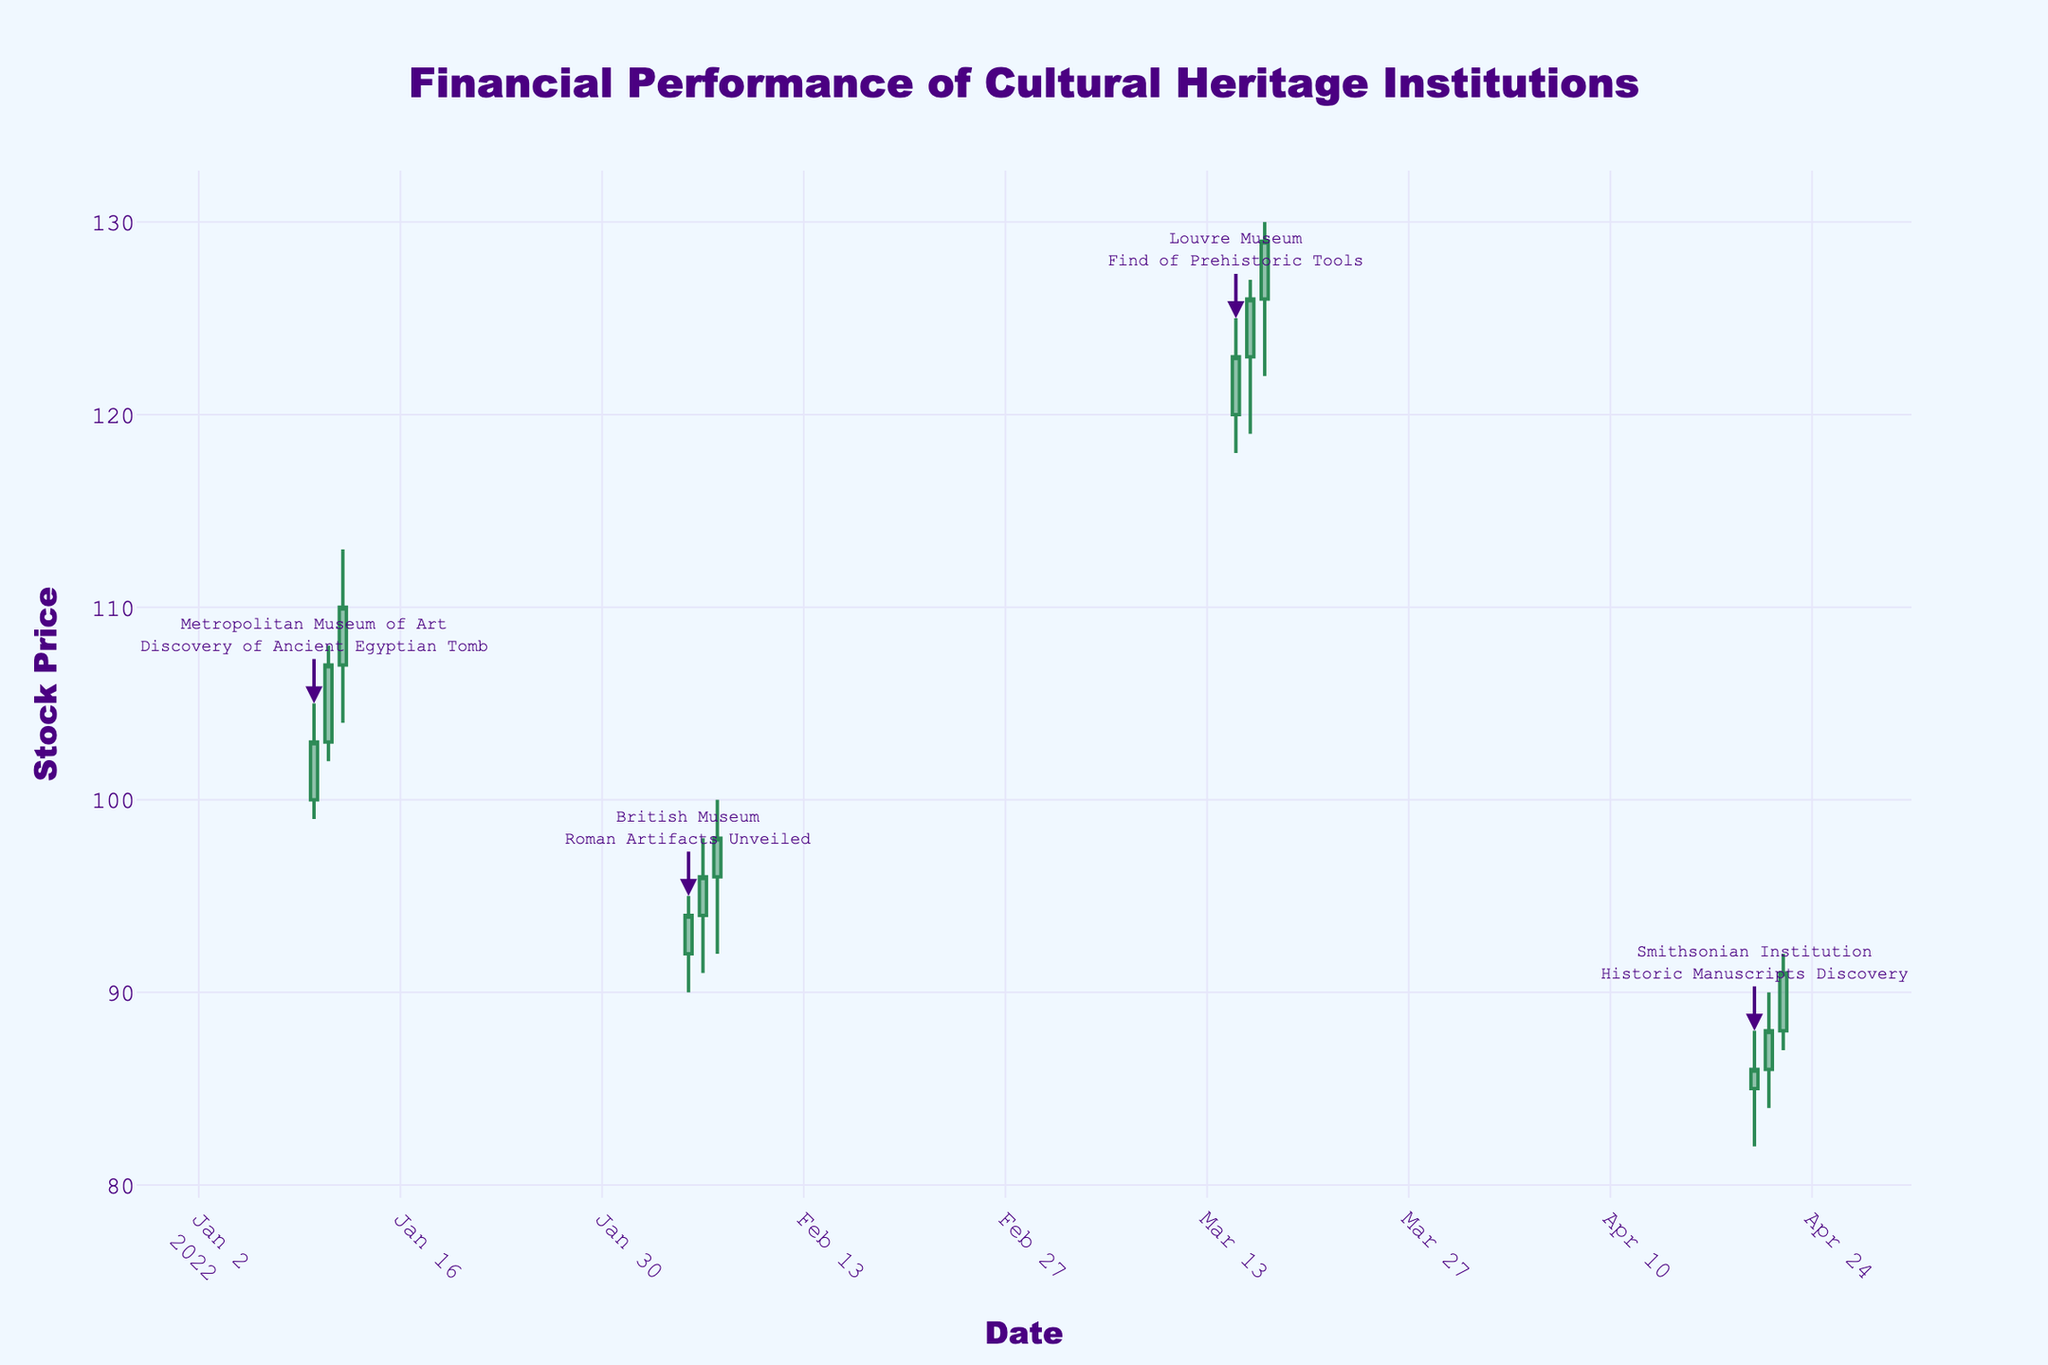What's the title of the plot? The title is usually displayed at the top of the plot. In this case, it is styled with a particular font and color, making it stand out.
Answer: Financial Performance of Cultural Heritage Institutions Which institution is associated with the events in March 2022? Look for labels or annotations around the dates in March. These should point to the institution involved.
Answer: Louvre Museum What is the lowest stock price recorded by the British Museum during the Roman Artifacts Unveiled event? Identify the candlestick bars corresponding to the British Museum and look at the lowest price during the specific event dates.
Answer: 90 On which date did the Metropolitan Museum of Art have the highest closing stock price? Look at the candlestick bars for the Metropolitan Museum of Art and find the bar with the highest close price. Refer to its date.
Answer: 2022-01-12 Between which dates did the Louvre Museum report the highest stock increase during the Find of Prehistoric Tools event? Compare the opening and closing prices of consecutive days during the Louvre Museum's event and identify the days with the highest increase.
Answer: 2022-03-15 to 2022-03-17 What is the overall trend in the stock price of the Smithsonian Institution during its event? Look at the direction of the candlestick bars (increasing or decreasing) during the Smithsonian Institution's event and summarize the trend.
Answer: Increasing What is the average closing price of the Louvre Museum during the Find of Prehistoric Tools event? Sum the closing prices of the Louvre Museum during the event days and divide by the number of days.
Answer: 126 How does the stock price movement of the British Museum compare to that of the Smithsonian Institution on the last day of their respective events? Compare the close prices on the last day of their events. Look at the increasing or decreasing nature of each bar.
Answer: British Museum closes at 98, while the Smithsonian Institution closes at 91 Which institution had the highest trading volume and on which date? Cross-reference the volume data for each institution and identify the highest value, then check the associated date.
Answer: Louvre Museum on 2022-03-17 What was the range (high minus low) of stock prices for the Metropolitan Museum of Art on 2022-01-11? Subtract the lowest price from the highest price for the date in question.
Answer: 6 